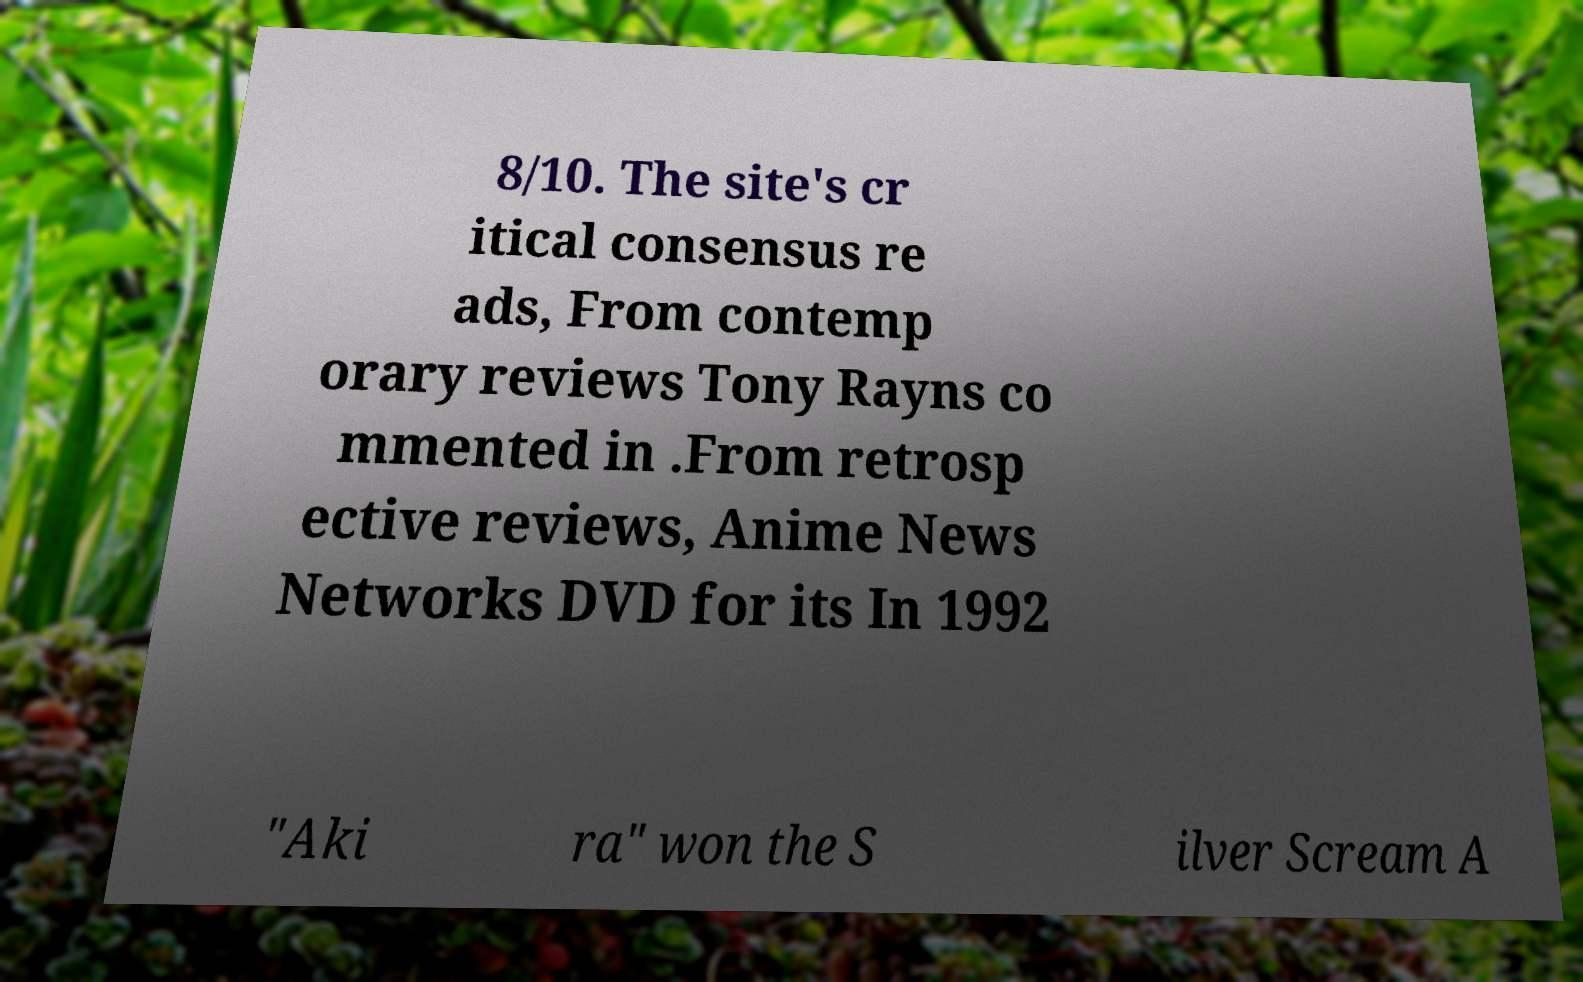Could you assist in decoding the text presented in this image and type it out clearly? 8/10. The site's cr itical consensus re ads, From contemp orary reviews Tony Rayns co mmented in .From retrosp ective reviews, Anime News Networks DVD for its In 1992 "Aki ra" won the S ilver Scream A 